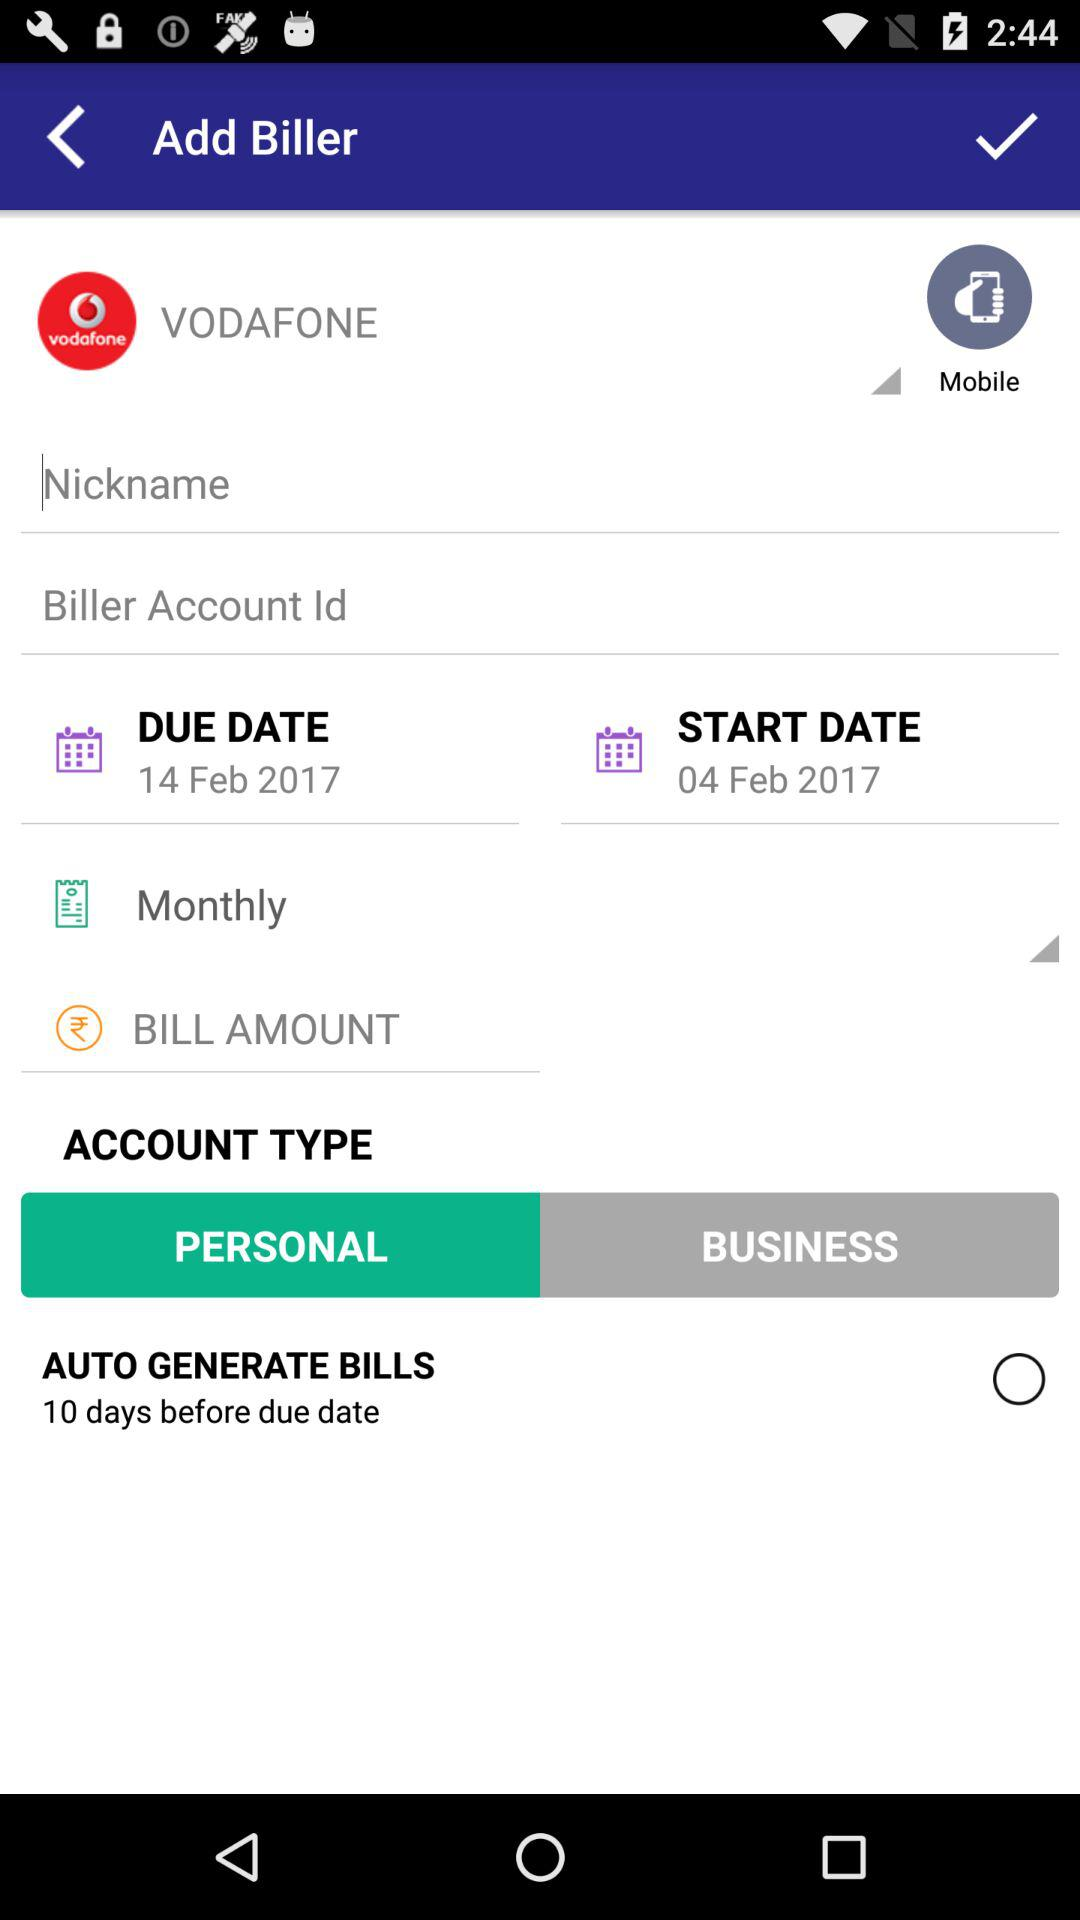What is the start date? The start date is February 4, 2017. 